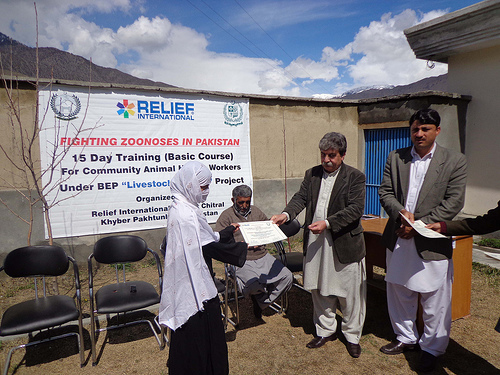<image>
Is the woman on the chair? No. The woman is not positioned on the chair. They may be near each other, but the woman is not supported by or resting on top of the chair. Is there a man to the left of the man? Yes. From this viewpoint, the man is positioned to the left side relative to the man. 